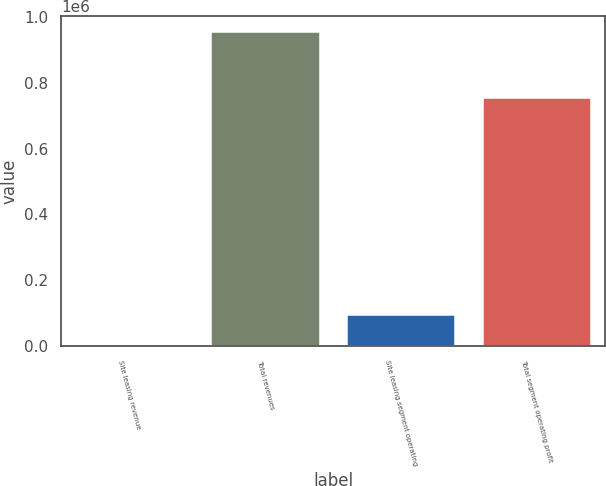Convert chart to OTSL. <chart><loc_0><loc_0><loc_500><loc_500><bar_chart><fcel>Site leasing revenue<fcel>Total revenues<fcel>Site leasing segment operating<fcel>Total segment operating profit<nl><fcel>88.7<fcel>954084<fcel>95488.2<fcel>752543<nl></chart> 